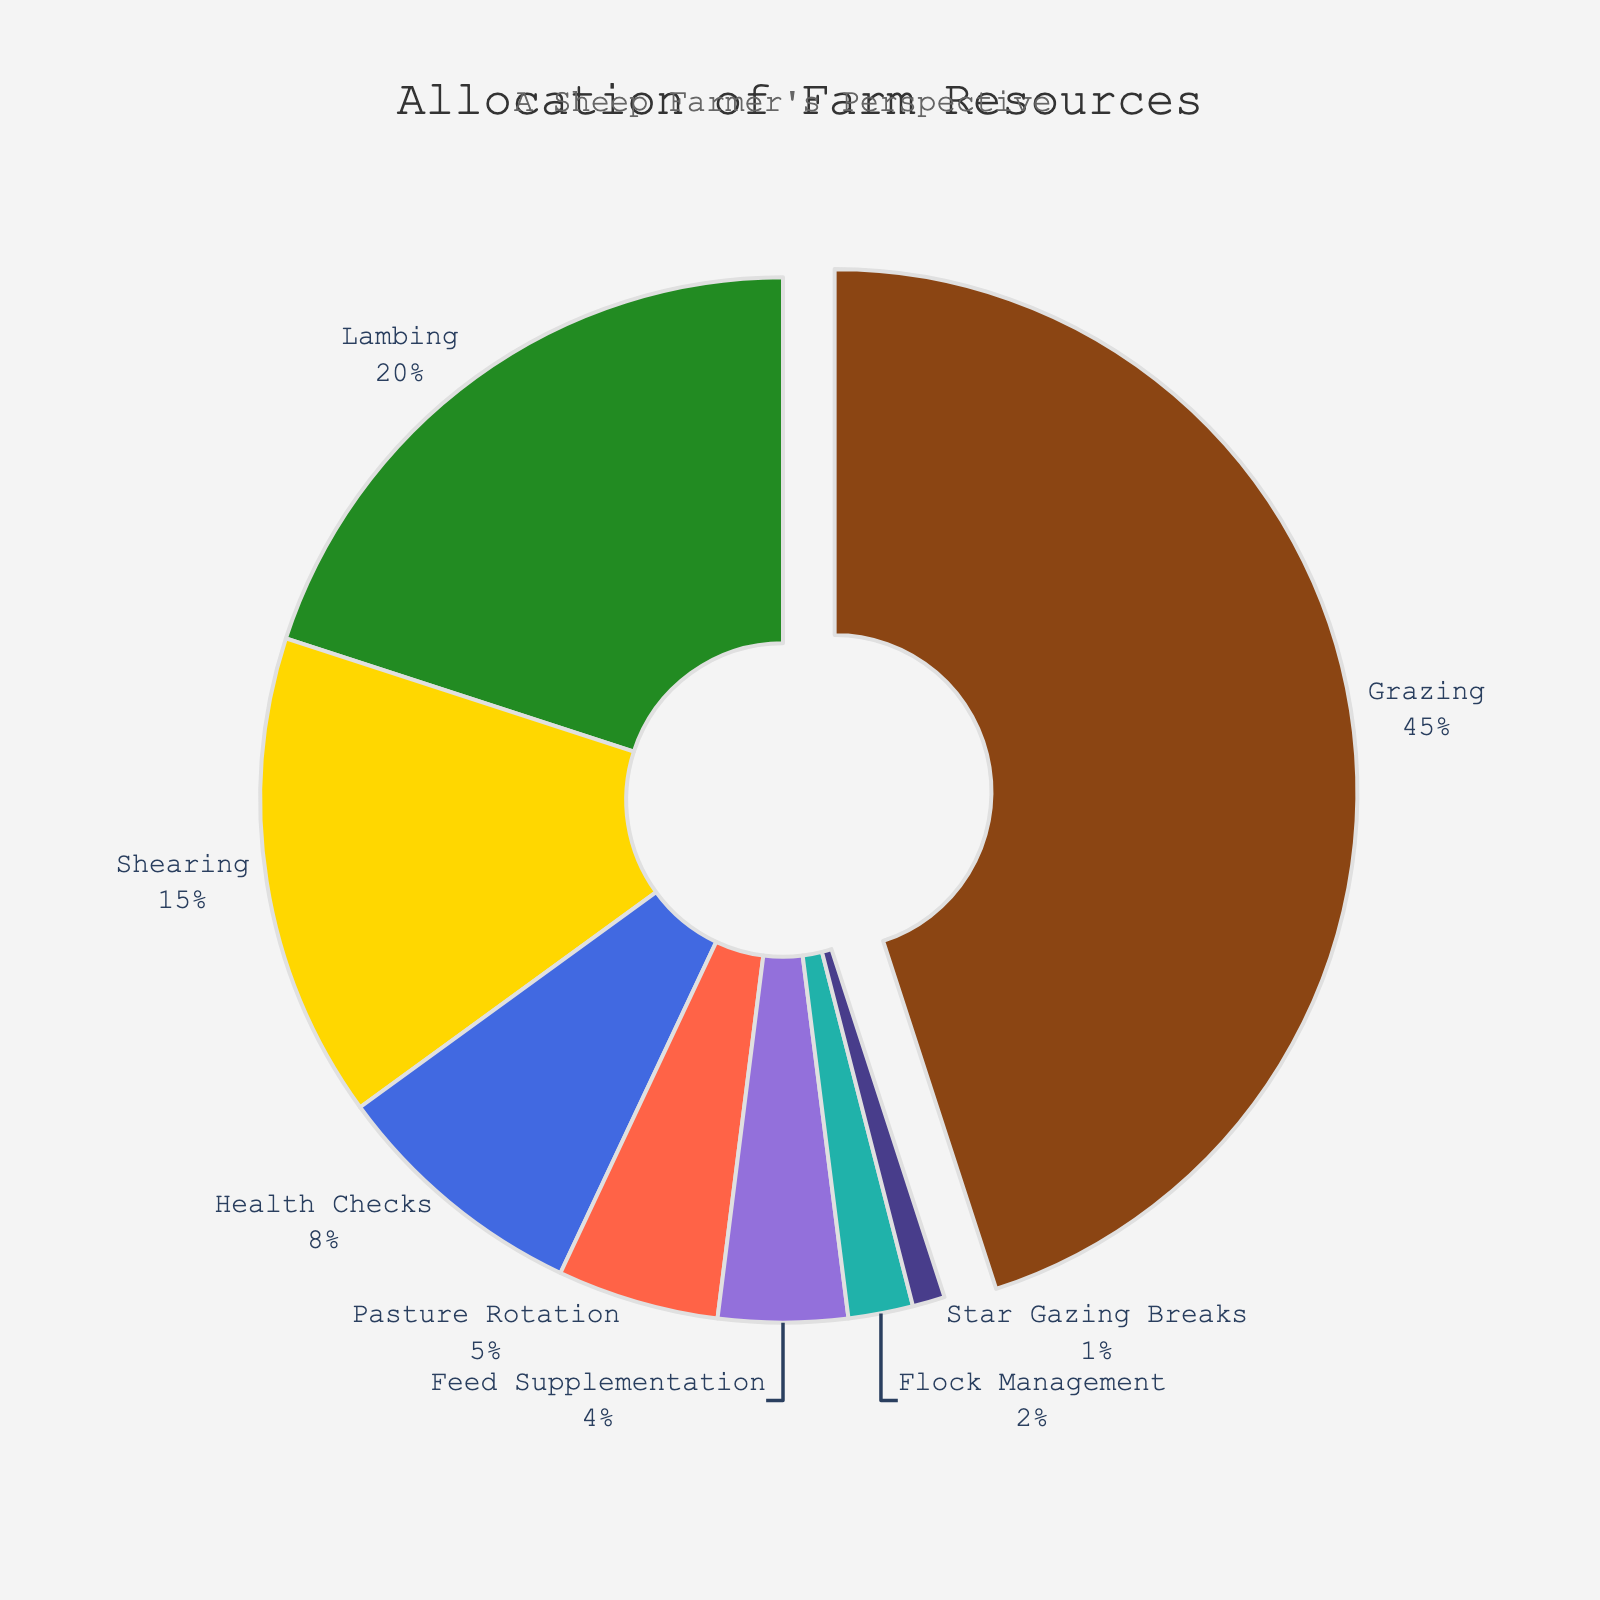What is the largest allocation of farm resources? The largest slice of the pie chart is the "Grazing" activity, which is visually the biggest portion and also specifically pulled out. By referring to the percentage, Grazing constitutes 45%, which is the highest of all percentages.
Answer: Grazing What percentage of resources is allocated to Lambing compared to Shearing? From the chart, Lambing gets 20% of the resources and Shearing gets 15%. To find the comparison, simply look at the percentages and observe that Lambing has a larger allocation.
Answer: Lambing has more with 20% compared to Shearing's 15% What is the combined allocation percentage for Health Checks, Pasture Rotation, and Feed Supplementation? To get the combined percentage, add the percentages for Health Checks (8%), Pasture Rotation (5%), and Feed Supplementation (4%). 8% + 5% + 4% = 17%.
Answer: 17% Which activity is represented by a light blue color in the pie chart? Observing the pie chart, the activity associated with the light blue color is "Pasture Rotation." This is indicated in the legend.
Answer: Pasture Rotation Is the resource allocation for Star Gazing Breaks greater or less than that for Flock Management? The pie chart shows that Star Gazing Breaks have 1% of resources while Flock Management has 2%. Therefore, Star Gazing Breaks have a smaller allocation.
Answer: Less In terms of resource allocation, which activities combined have a larger percentage than Grazing alone? First, note Grazing is 45%. Then add the percentages of the next largest activities: Lambing (20%) and Shearing (15%), which sum to 35%. Adding another small activity, Health Checks (8%) brings it to 43%. Adding one more minor activity, Pasture Rotation (5%), surpasses 45%. So, Lambing, Shearing, and Health Checks combined already exceed Grazing.
Answer: Yes, Lambing, Shearing, and Health Checks combined have more How much more is allocated to Grazing compared to the Star Gazing Breaks? Grazing is allocated 45%, while Star Gazing Breaks get 1%. Subtract 1% from 45% to find the difference. 45% - 1% = 44%.
Answer: 44% Which activity receives the least amount of resource allocation and what percentage is it? The smallest portion of the pie chart corresponds to "Star Gazing Breaks," which has an allocation of 1%.
Answer: Star Gazing Breaks, 1% What is the difference in resource allocation between Pasture Rotation and Feed Supplementation? The chart shows Pasture Rotation gets 5% and Feed Supplementation gets 4%. To find the difference, subtract the smaller percentage from the larger one. 5% - 4% = 1%.
Answer: 1% Which activities together account for exactly half of the farm's resource allocation? We need to identify activities that sum up to 50%. Grazing (45%) + Pasture Rotation (5%) exactly makes 50%.
Answer: Grazing and Pasture Rotation 